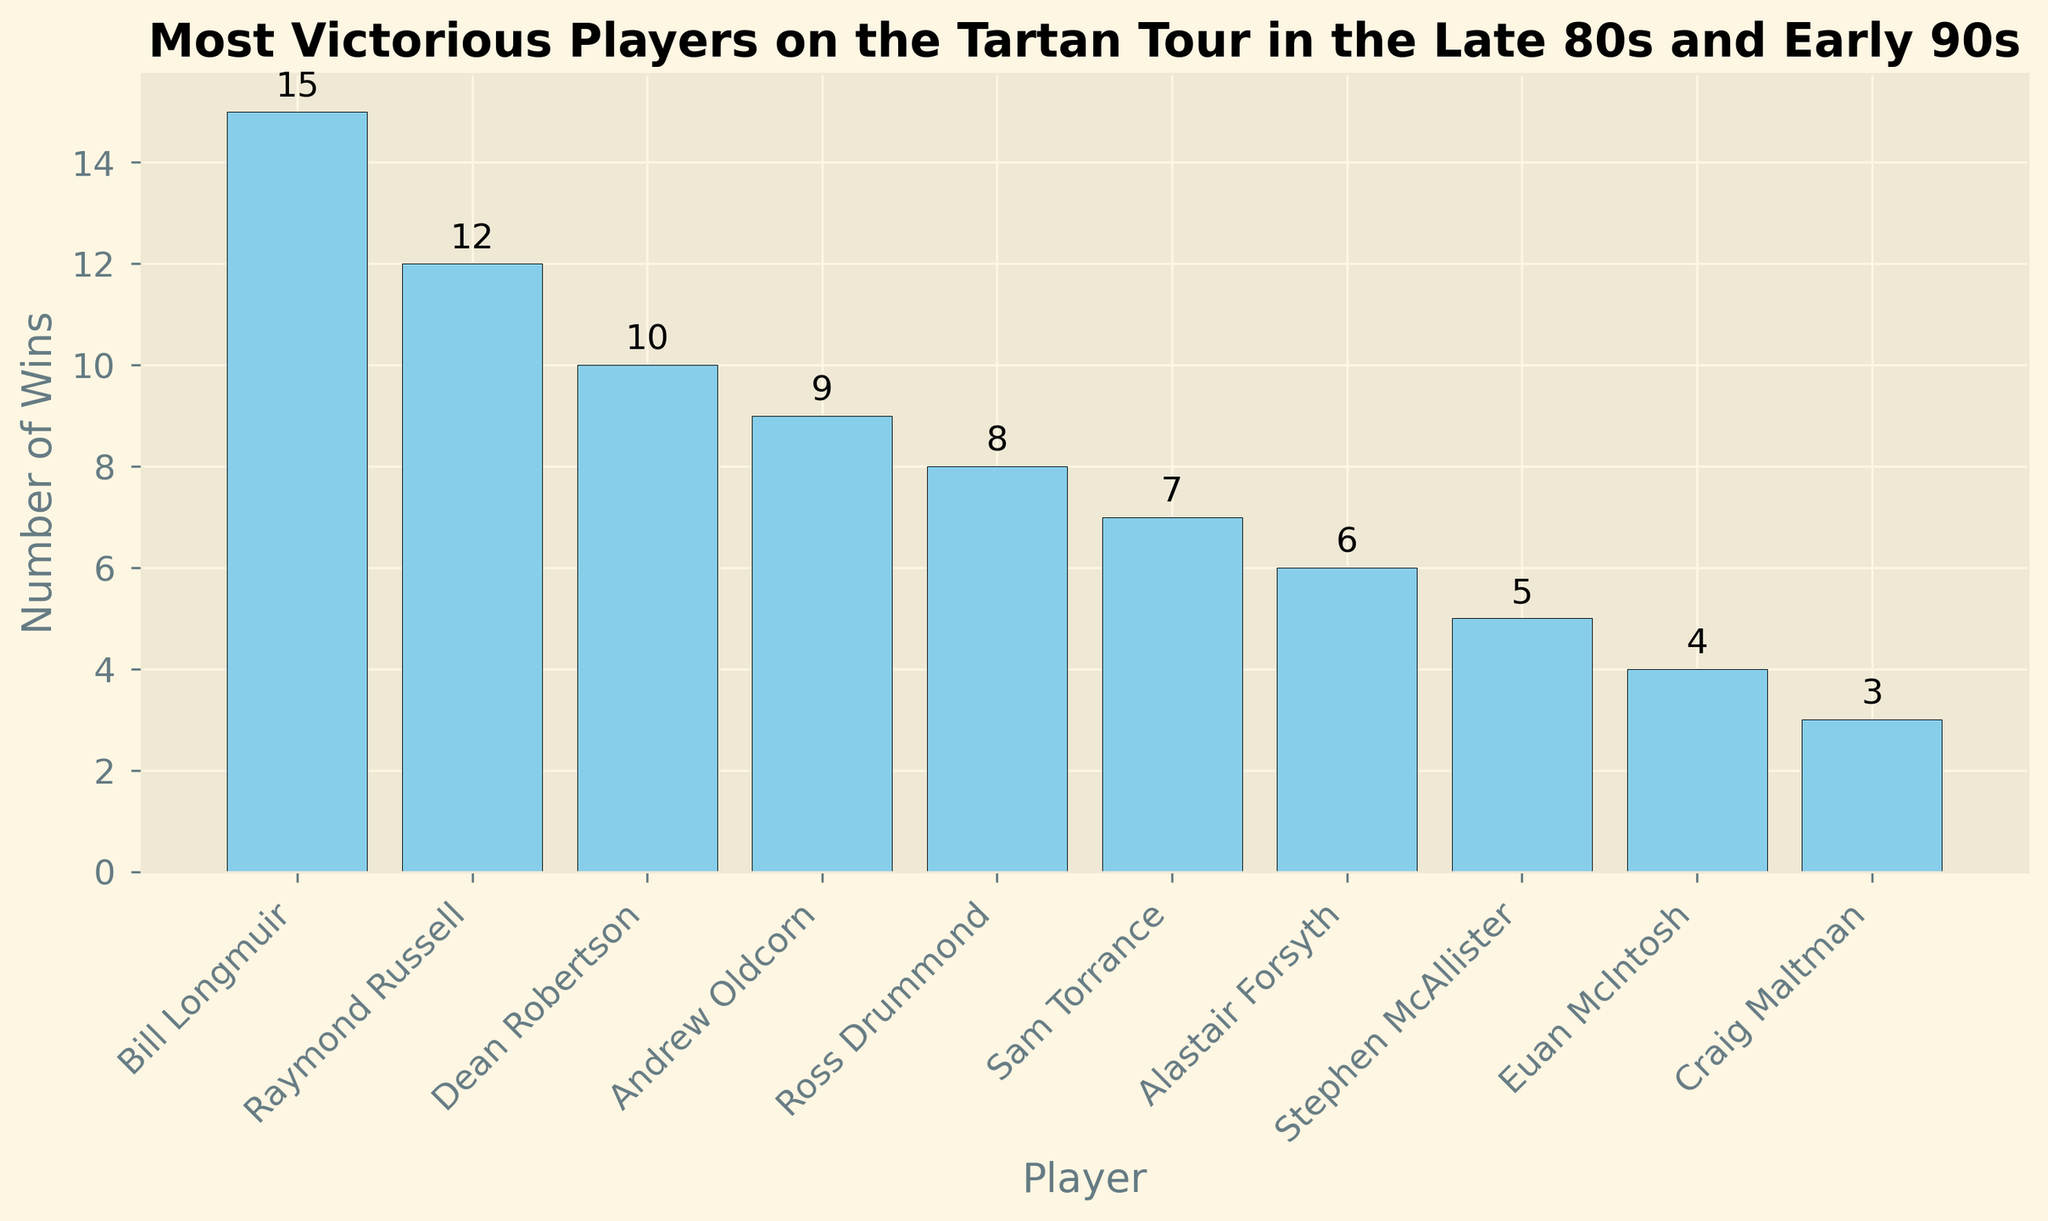Which player has the most number of wins on the Tartan Tour in the late 80s and early 90s? The player with the tallest bar on the bar chart represents the player with the most wins. In this case, Bill Longmuir has the highest number of wins.
Answer: Bill Longmuir Who are the top three players with the highest number of wins? Identify the top three bars by height in descending order. The top three players are Bill Longmuir, Raymond Russell, and Dean Robertson.
Answer: Bill Longmuir, Raymond Russell, Dean Robertson What is the difference in the number of wins between the player with the most wins and the player with the least wins? Subtract the number of wins of the player with the least wins from the number of wins of the player with the most wins. Bill Longmuir has 15 wins, and Craig Maltman has 3 wins. Therefore, 15 - 3 = 12.
Answer: 12 How many players have won more than 7 tournaments? Evaluate the bars representing players who have won more than 7 tournaments. Bill Longmuir, Raymond Russell, Dean Robertson, and Andrew Oldcorn all have more than 7 wins.
Answer: 4 What is the total number of wins by the top five players? Sum the number of wins for the top five players: Bill Longmuir (15), Raymond Russell (12), Dean Robertson (10), Andrew Oldcorn (9), and Ross Drummond (8). Adding these together, 15 + 12 + 10 + 9 + 8 = 54.
Answer: 54 Who has more wins: Andrew Oldcorn or Ross Drummond? Compare the number of wins between Andrew Oldcorn and Ross Drummond. Andrew Oldcorn has 9 wins, while Ross Drummond has 8. Andrew Oldcorn has more wins.
Answer: Andrew Oldcorn What is the average number of wins for the players listed? Sum the total number of wins for all players and divide by the number of players. The total number of wins is 15 + 12 + 10 + 9 + 8 + 7 + 6 + 5 + 4 + 3 = 79. There are 10 players. Therefore, 79 / 10 = 7.9.
Answer: 7.9 Who has the fewest number of wins on the list? Identify the player with the shortest bar on the bar chart. Craig Maltman has the fewest wins with 3.
Answer: Craig Maltman How many more wins does Sam Torrance have compared to the player with the least number of wins? Find the difference between Sam Torrance's wins and the player with the least wins. Sam Torrance has 7 wins, and Craig Maltman has 3 wins. Thus, 7 - 3 = 4.
Answer: 4 